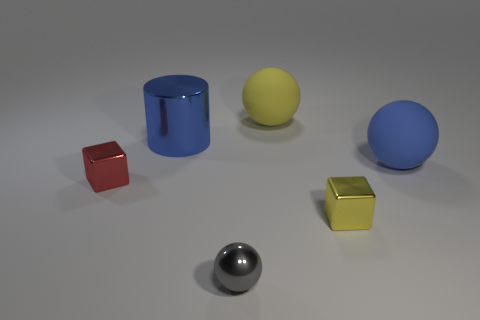Add 3 small matte spheres. How many objects exist? 9 Subtract all cylinders. How many objects are left? 5 Subtract all big matte spheres. Subtract all tiny spheres. How many objects are left? 3 Add 2 big blue cylinders. How many big blue cylinders are left? 3 Add 4 large purple metallic things. How many large purple metallic things exist? 4 Subtract 0 gray blocks. How many objects are left? 6 